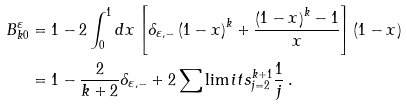<formula> <loc_0><loc_0><loc_500><loc_500>B _ { k 0 } ^ { \varepsilon } & = 1 - 2 \int _ { 0 } ^ { 1 } d x \left [ \delta _ { \varepsilon , - } \left ( 1 - x \right ) ^ { k } + \frac { \left ( 1 - x \right ) ^ { k } - 1 } { x } \right ] \left ( 1 - x \right ) \\ & = 1 - \frac { 2 } { k + 2 } \delta _ { \varepsilon , - } + 2 \sum \lim i t s _ { j = 2 } ^ { k + 1 } \frac { 1 } { j } \, .</formula> 